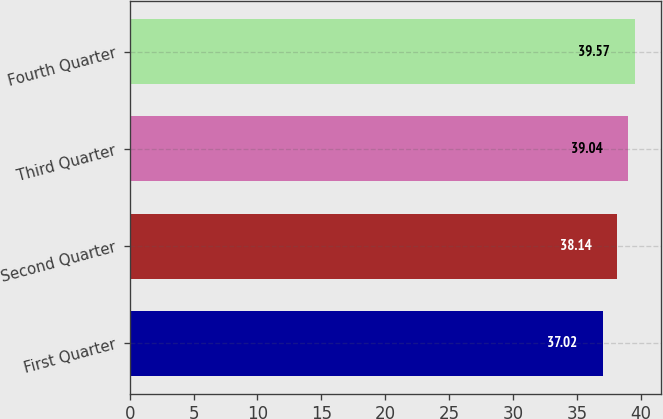<chart> <loc_0><loc_0><loc_500><loc_500><bar_chart><fcel>First Quarter<fcel>Second Quarter<fcel>Third Quarter<fcel>Fourth Quarter<nl><fcel>37.02<fcel>38.14<fcel>39.04<fcel>39.57<nl></chart> 